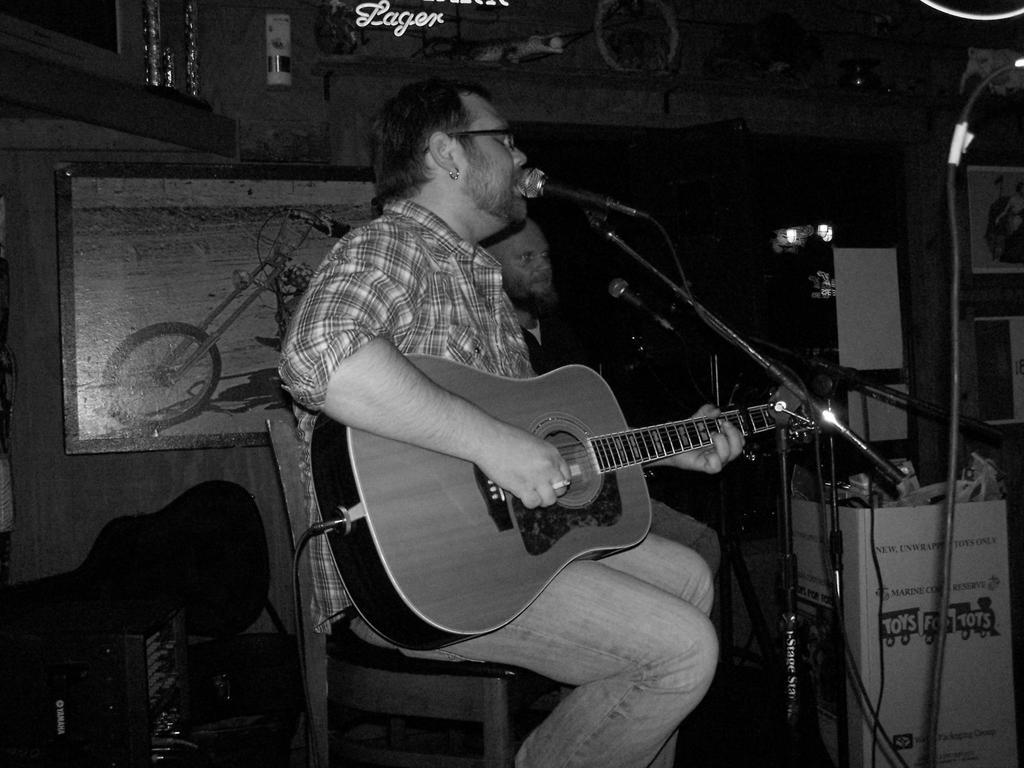What is the man in the image doing? The man is seated, playing a guitar, singing, and using a microphone. Can you describe the second man in the image? The second man is also seated in the image. What is the primary activity of the first man in the image? The primary activity of the first man is playing a guitar and singing. What type of mist can be seen surrounding the rabbits in the image? There are no rabbits or mist present in the image. 